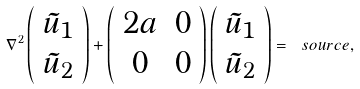Convert formula to latex. <formula><loc_0><loc_0><loc_500><loc_500>\nabla ^ { 2 } \left ( \begin{array} { c } \tilde { u } _ { 1 } \\ \tilde { u } _ { 2 } \end{array} \right ) + \left ( \begin{array} { c c } 2 a & 0 \\ 0 & 0 \end{array} \right ) \left ( \begin{array} { c } \tilde { u } _ { 1 } \\ \tilde { u } _ { 2 } \end{array} \right ) = \ s o u r c e ,</formula> 